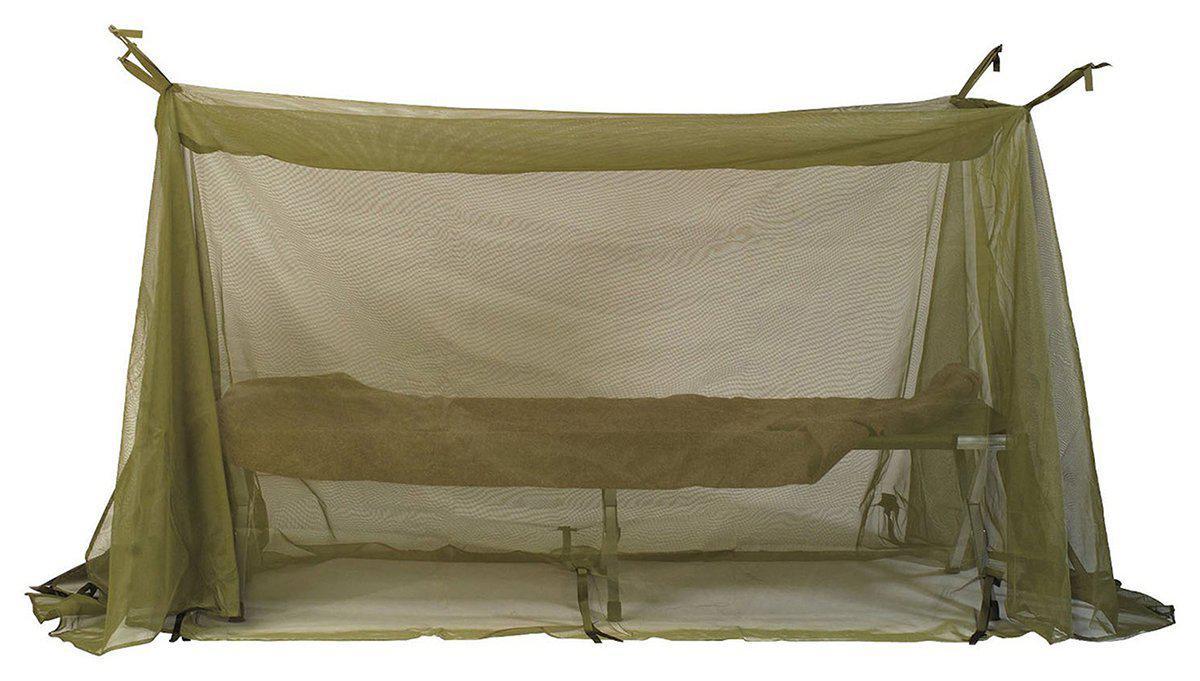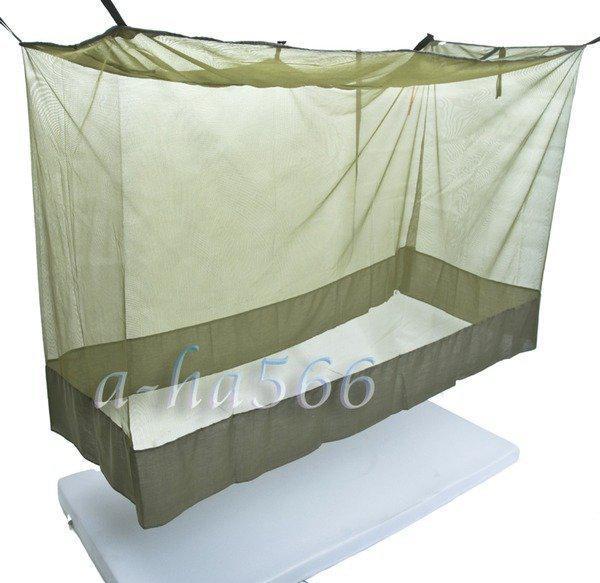The first image is the image on the left, the second image is the image on the right. Given the left and right images, does the statement "There is grass visible on one of the images." hold true? Answer yes or no. No. The first image is the image on the left, the second image is the image on the right. For the images shown, is this caption "there is a person in one of the images" true? Answer yes or no. No. 